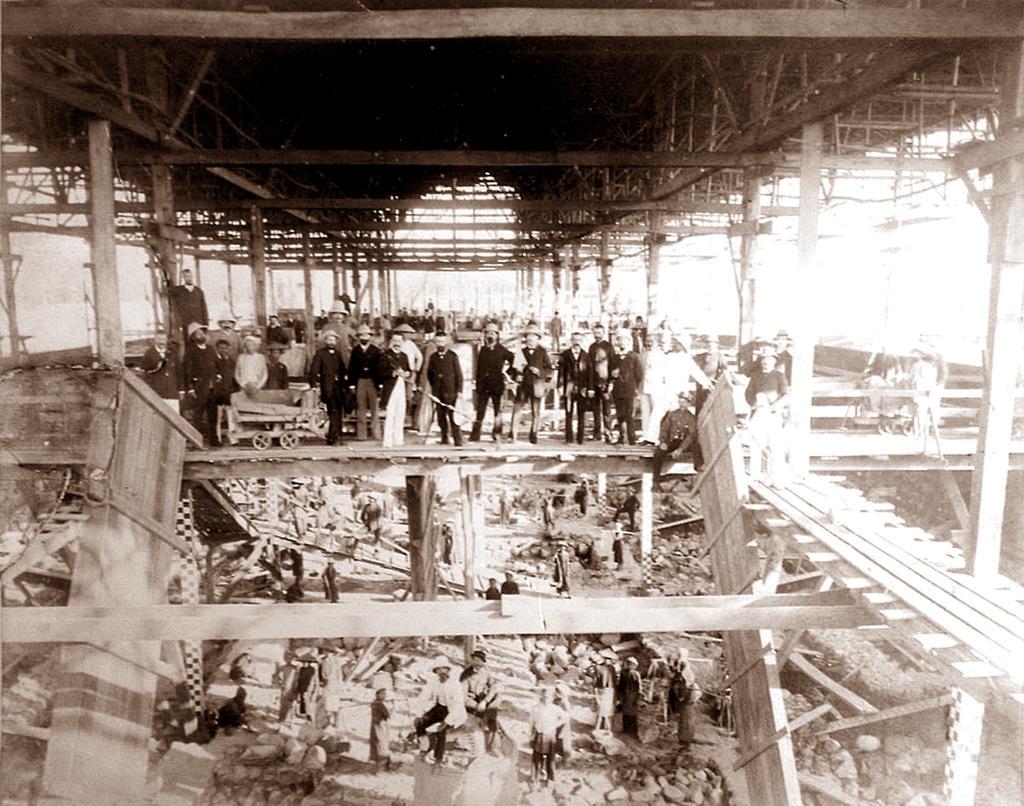Describe this image in one or two sentences. In this image I can see group of people standing. In front I can see the trolley, few poles and I can see few wooden objects. 